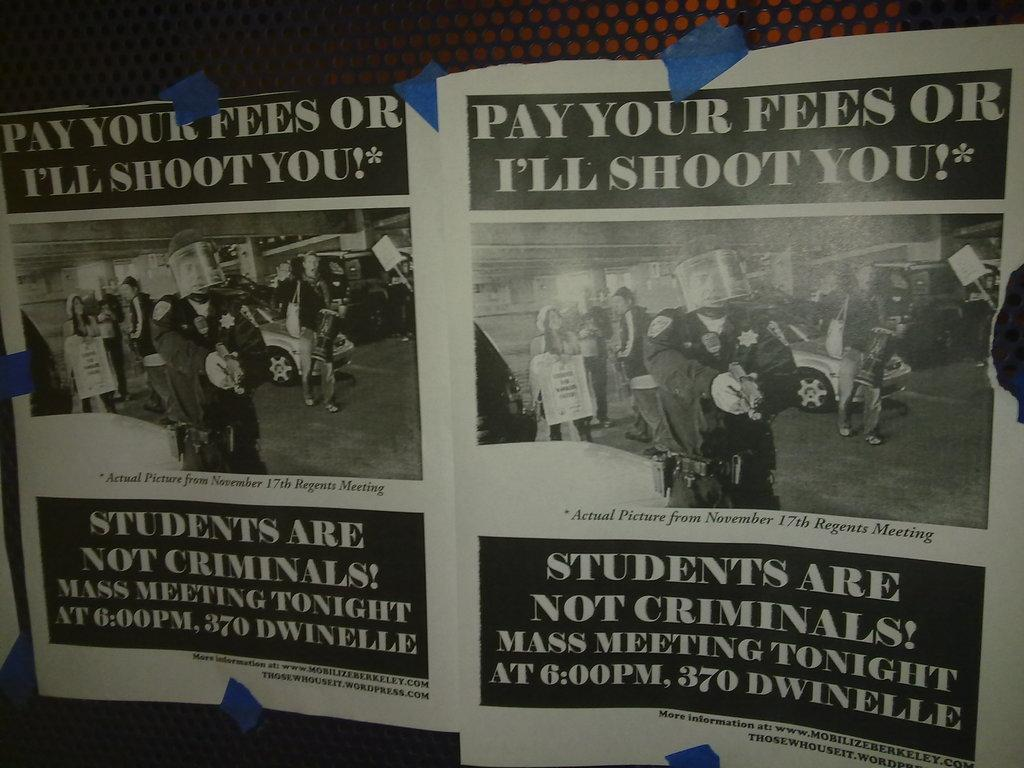<image>
Render a clear and concise summary of the photo. The scary poster states that you need to pay your fees or you will be shot. 